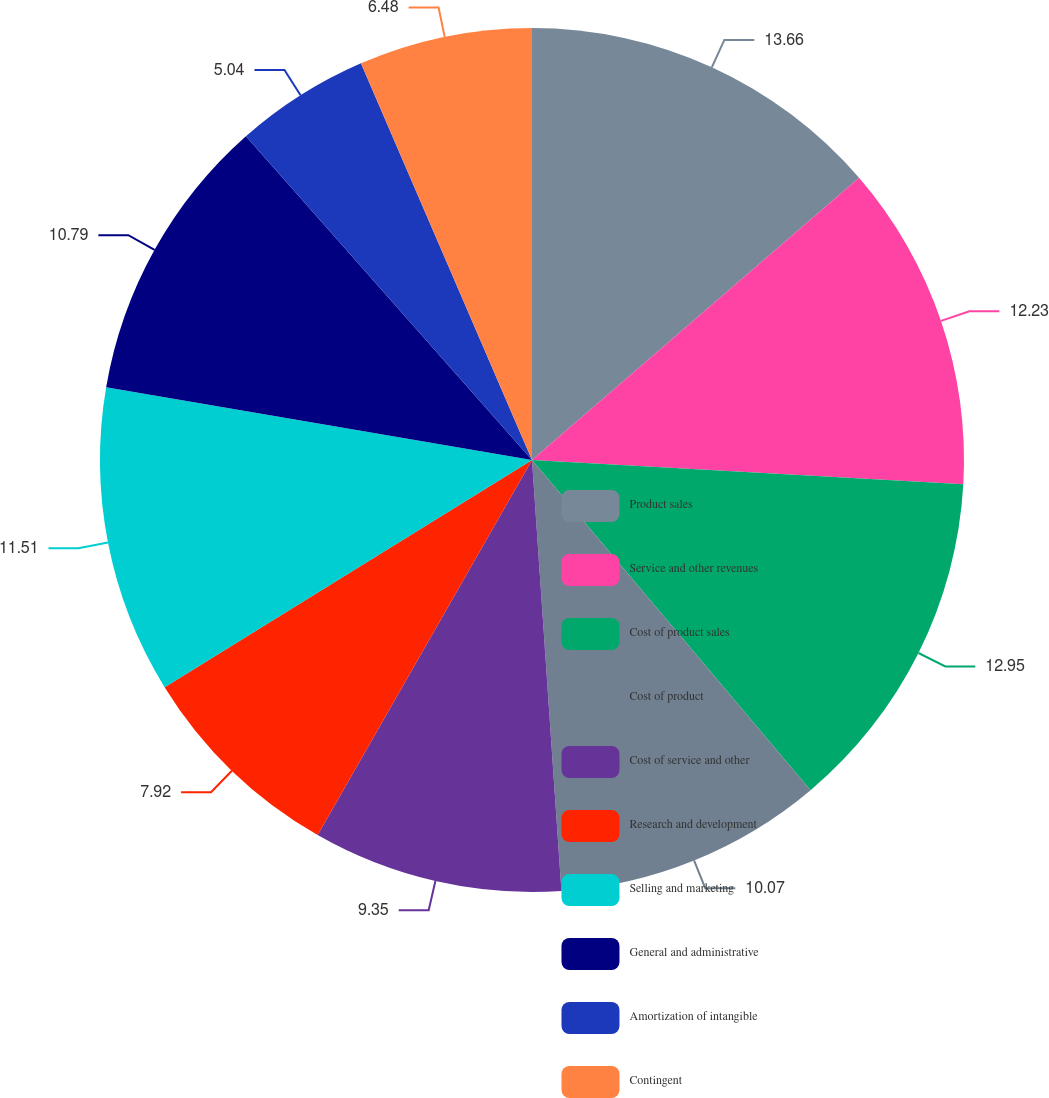<chart> <loc_0><loc_0><loc_500><loc_500><pie_chart><fcel>Product sales<fcel>Service and other revenues<fcel>Cost of product sales<fcel>Cost of product<fcel>Cost of service and other<fcel>Research and development<fcel>Selling and marketing<fcel>General and administrative<fcel>Amortization of intangible<fcel>Contingent<nl><fcel>13.67%<fcel>12.23%<fcel>12.95%<fcel>10.07%<fcel>9.35%<fcel>7.92%<fcel>11.51%<fcel>10.79%<fcel>5.04%<fcel>6.48%<nl></chart> 